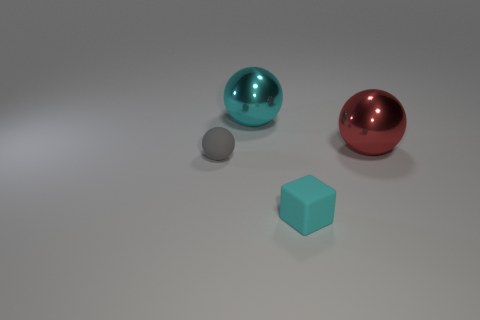Add 4 big metal spheres. How many objects exist? 8 Subtract all blocks. How many objects are left? 3 Add 1 gray objects. How many gray objects are left? 2 Add 3 tiny cyan rubber cubes. How many tiny cyan rubber cubes exist? 4 Subtract 0 blue balls. How many objects are left? 4 Subtract all cyan objects. Subtract all red shiny cubes. How many objects are left? 2 